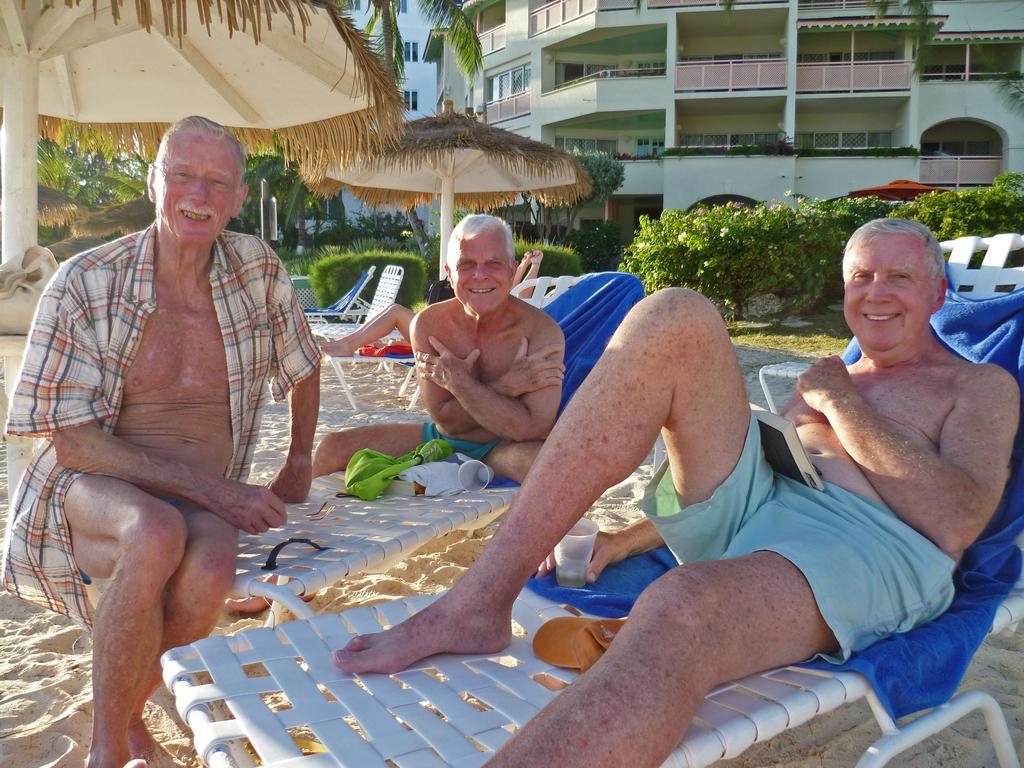Could you give a brief overview of what you see in this image? In the foreground, I can see a group of people on beds. In the background, I can see umbrella huts, house plants, grass, buildings and trees. This picture might be taken on the sandy beach. 